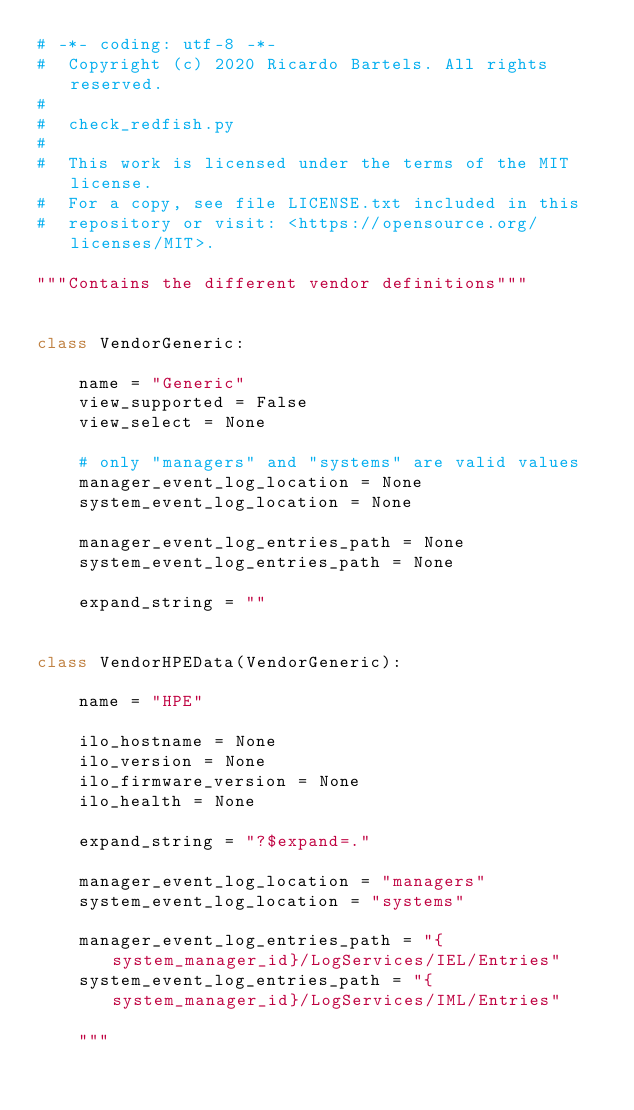<code> <loc_0><loc_0><loc_500><loc_500><_Python_># -*- coding: utf-8 -*-
#  Copyright (c) 2020 Ricardo Bartels. All rights reserved.
#
#  check_redfish.py
#
#  This work is licensed under the terms of the MIT license.
#  For a copy, see file LICENSE.txt included in this
#  repository or visit: <https://opensource.org/licenses/MIT>.

"""Contains the different vendor definitions"""


class VendorGeneric:

    name = "Generic"
    view_supported = False
    view_select = None

    # only "managers" and "systems" are valid values
    manager_event_log_location = None
    system_event_log_location = None

    manager_event_log_entries_path = None
    system_event_log_entries_path = None

    expand_string = ""


class VendorHPEData(VendorGeneric):

    name = "HPE"

    ilo_hostname = None
    ilo_version = None
    ilo_firmware_version = None
    ilo_health = None

    expand_string = "?$expand=."

    manager_event_log_location = "managers"
    system_event_log_location = "systems"

    manager_event_log_entries_path = "{system_manager_id}/LogServices/IEL/Entries"
    system_event_log_entries_path = "{system_manager_id}/LogServices/IML/Entries"

    """</code> 